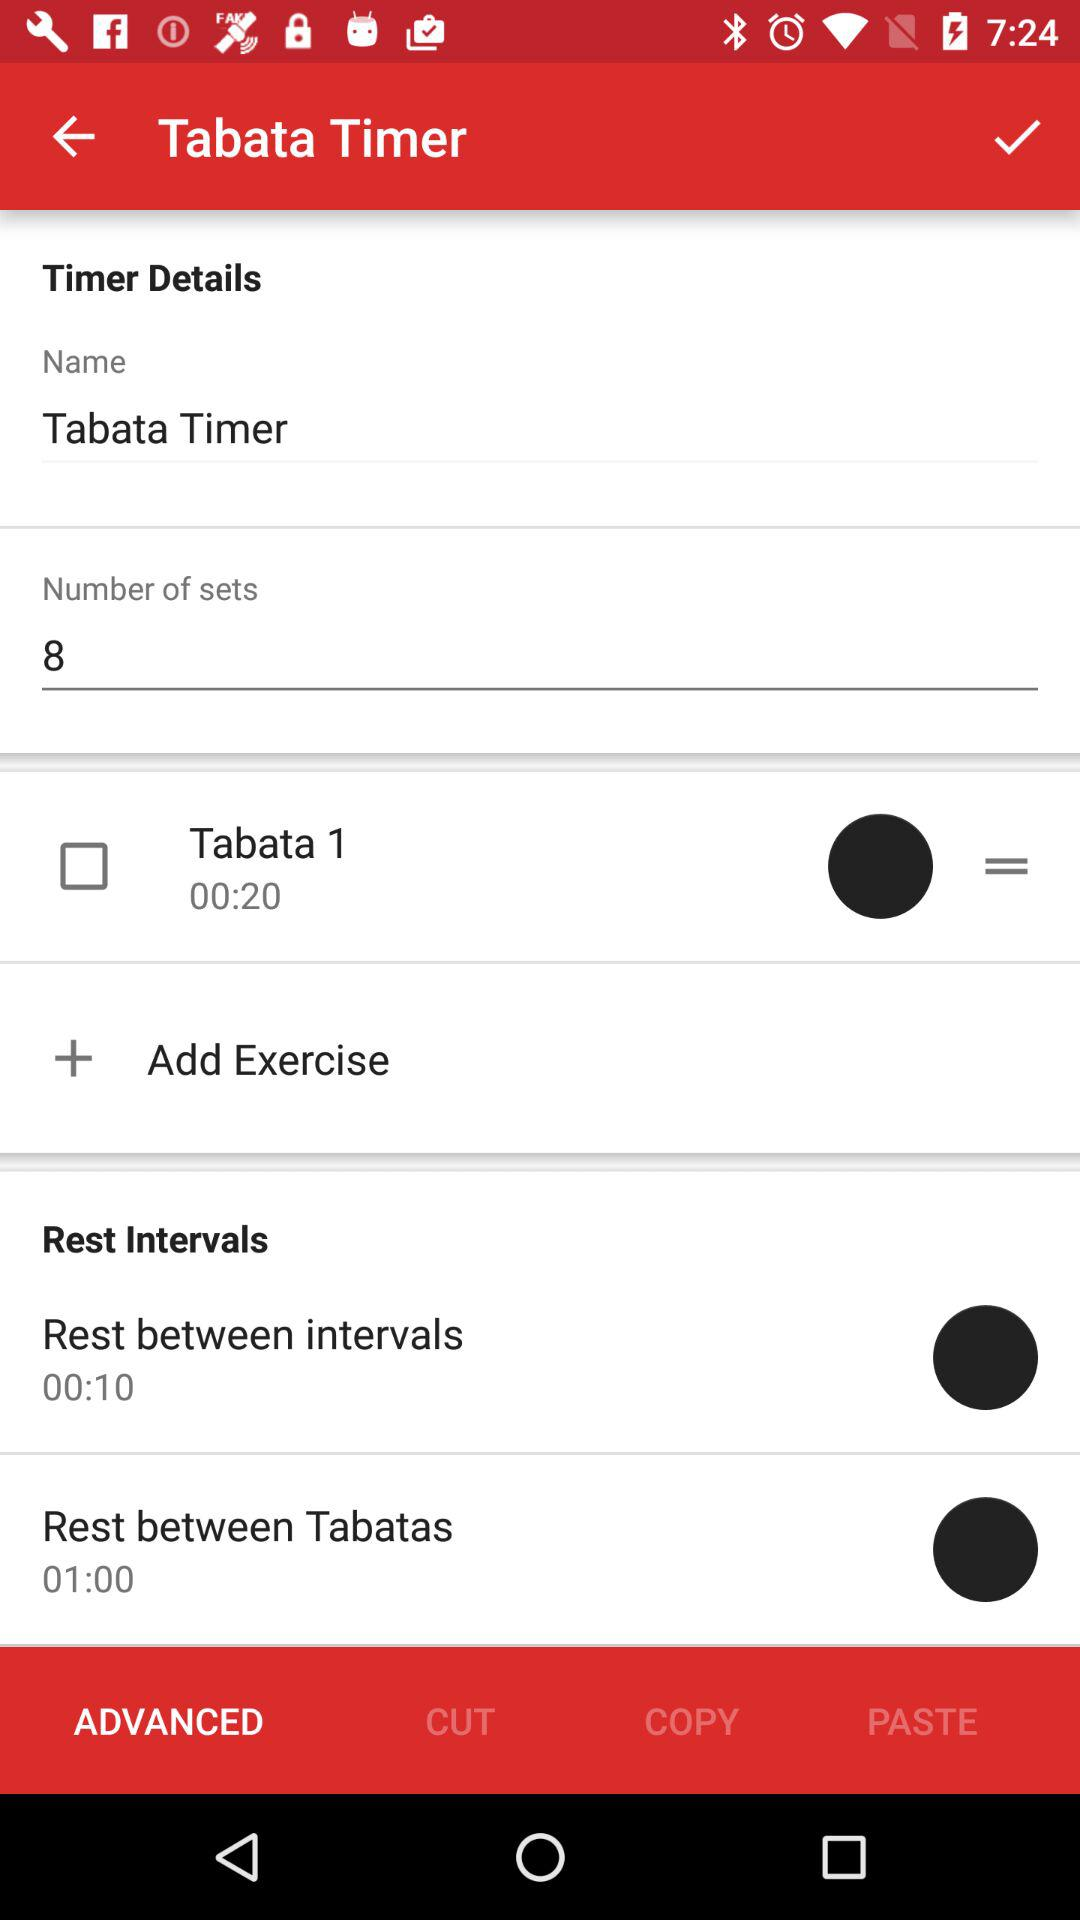How many Tabata sets are there?
Answer the question using a single word or phrase. 8 